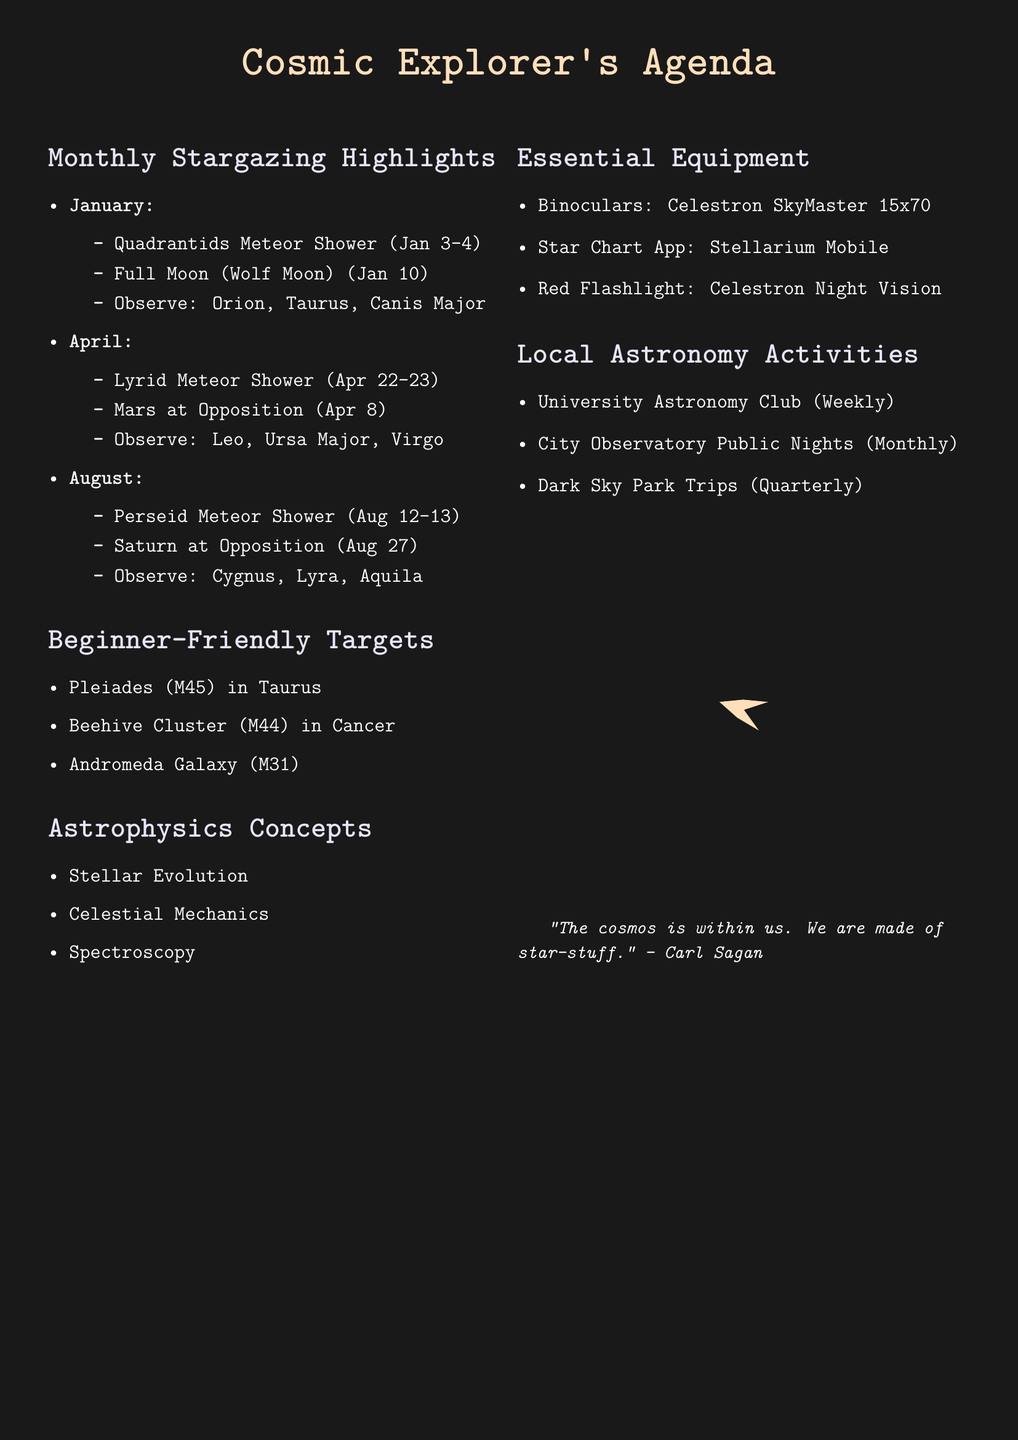What are the dates for the Quadrantids Meteor Shower? The Quadrantids Meteor Shower occurs on January 3-4 as mentioned in the schedule.
Answer: January 3-4 What is the viewing tip for the Full Moon in January? The viewing tip for the Full Moon (Wolf Moon) is to observe it as it rises at sunset and is visible all night.
Answer: Rises at sunset, visible all night Which constellation should be observed during the Lyrid Meteor Shower? The Lyrid Meteor Shower is best viewed towards the constellation Lyra, according to the document.
Answer: Lyra What is the beginner-friendly target located in the Taurus constellation? The beginner-friendly target in the Taurus constellation is the Pleiades (M45), as stated in the document.
Answer: Pleiades (M45) How often does the City Observatory host public nights? The frequency of City Observatory public nights is stated as monthly in the document, outlining the schedule for local astronomy activities.
Answer: Monthly What astrophysics topic helps interpret the night sky? Stellar Evolution is mentioned as a relevant topic for understanding the life cycles of stars, which helps interpret the night sky.
Answer: Stellar Evolution Which celestial event occurs on August 27? The document states that Saturn at Opposition occurs on August 27.
Answer: Saturn at Opposition What equipment is recommended for beginners to observe the night sky? The document recommends binoculars, specifically the Celestron SkyMaster 15x70, for beginners.
Answer: Binoculars: Celestron SkyMaster 15x70 